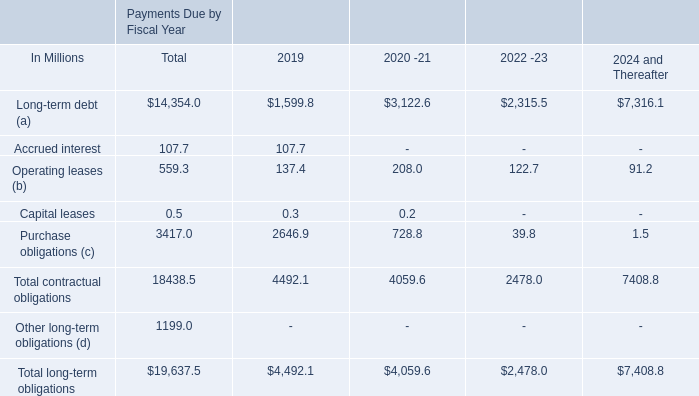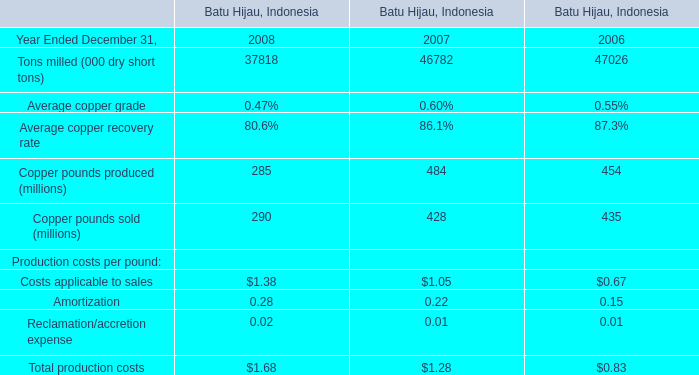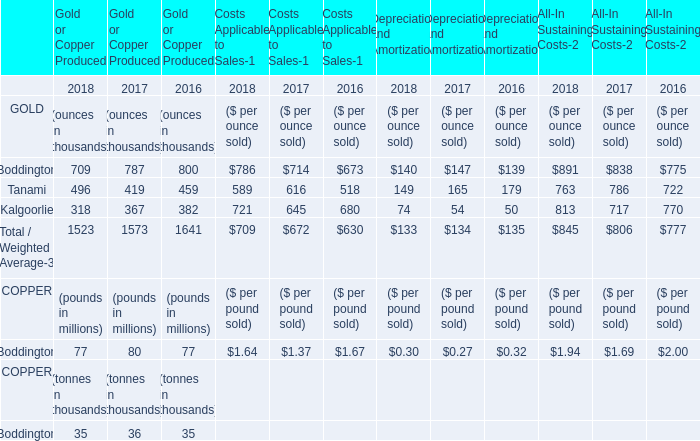in 2019 what was the ratio of the anticipated future payments for the post-employment benefit plans and deferred compensation 
Computations: (20 / 18)
Answer: 1.11111. 